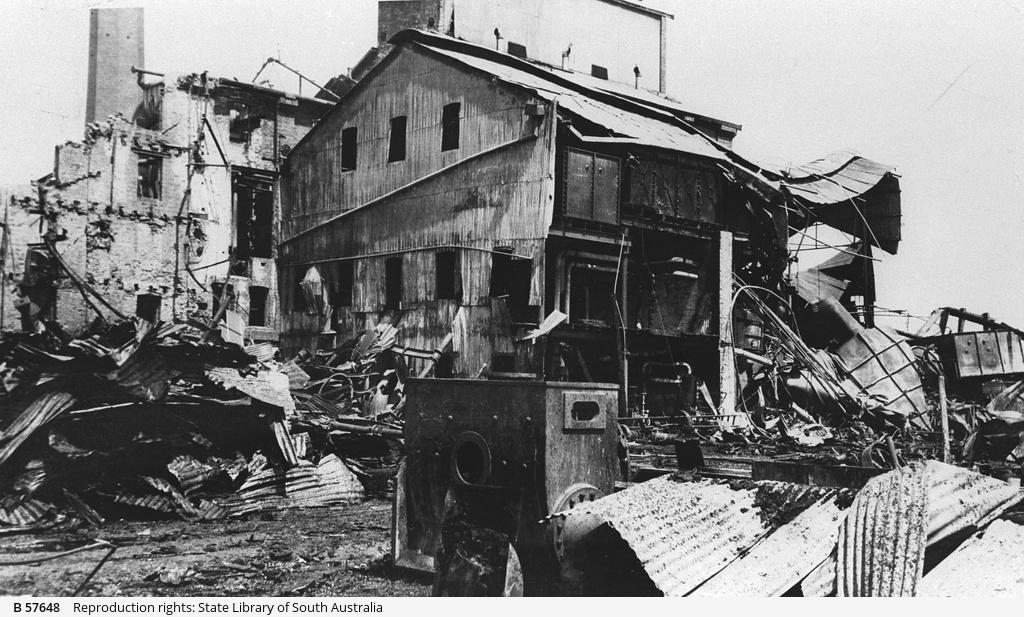What is the color scheme of the image? The image is black and white. What type of structures can be seen in the image? There are destroyed buildings in the image. What else can be observed in the image besides the destroyed buildings? There is scrap visible in the image. How many dolls can be seen playing in the spring in the image? There are no dolls or springs present in the image; it features destroyed buildings and scrap. 